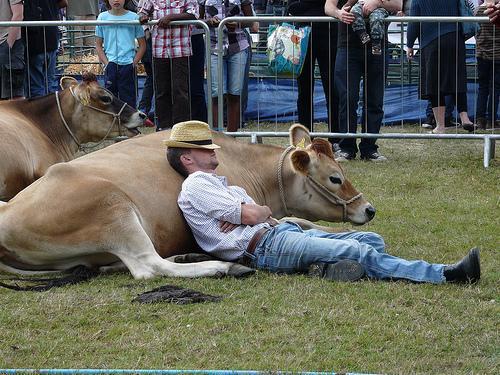How many cows are in the photo?
Give a very brief answer. 2. How many people are sitting down in the picture?
Give a very brief answer. 1. How many people are in the cow pen in this image?
Give a very brief answer. 1. 